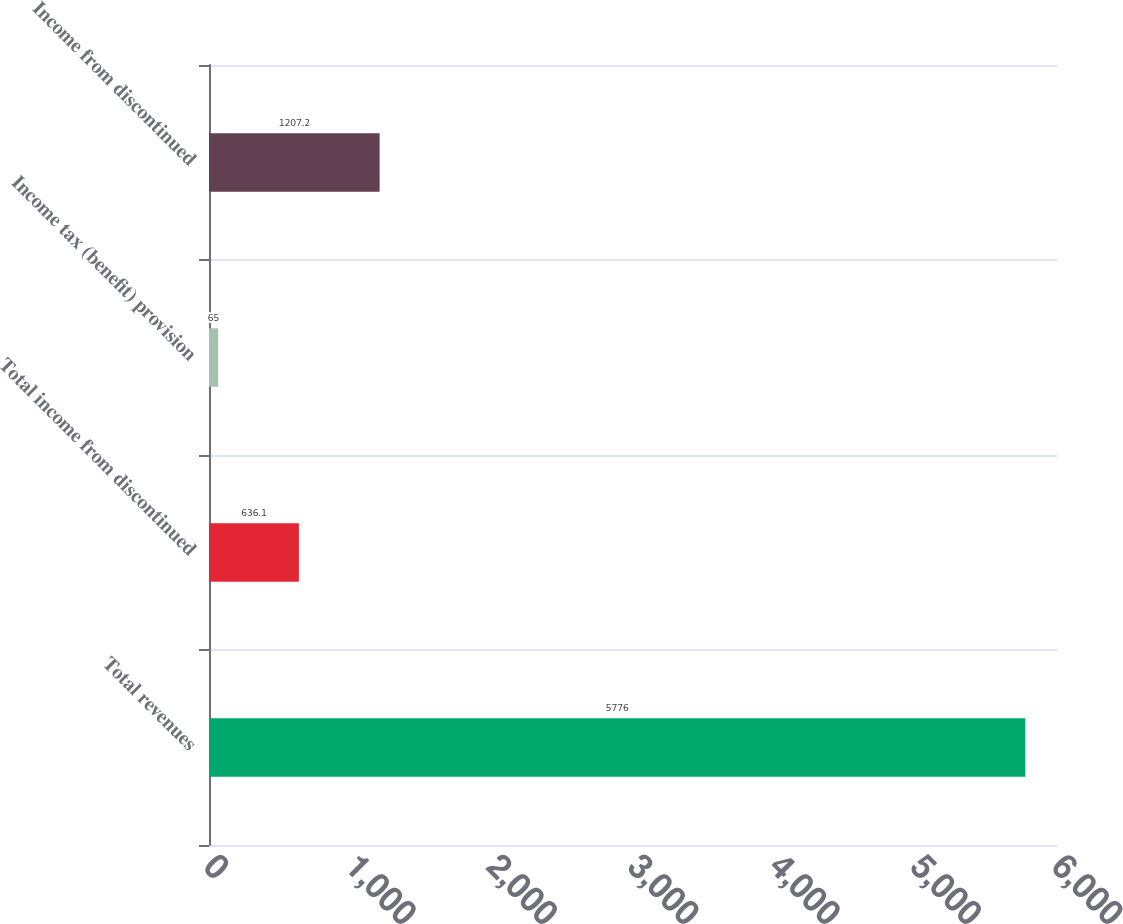Convert chart to OTSL. <chart><loc_0><loc_0><loc_500><loc_500><bar_chart><fcel>Total revenues<fcel>Total income from discontinued<fcel>Income tax (benefit) provision<fcel>Income from discontinued<nl><fcel>5776<fcel>636.1<fcel>65<fcel>1207.2<nl></chart> 